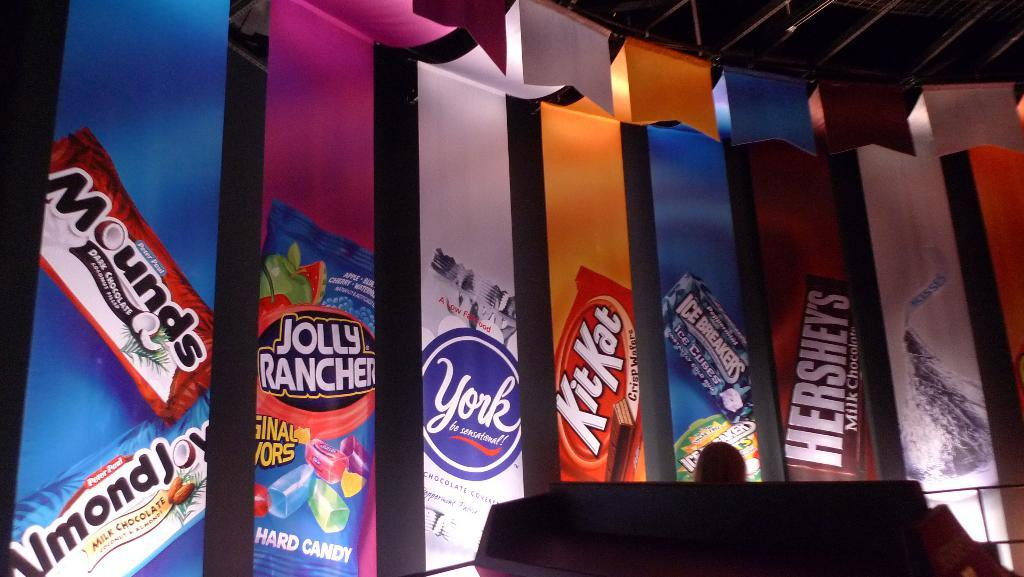What can be seen hanging from the rods and ropes at the top of the image? There are banners in the image that are hanging from the rods and ropes. What are the rods and ropes used for in the image? The rods and ropes are used to hold up the banners in the image. What color is the object at the bottom of the image? There is a black color object at the bottom of the image. Can you identify any human features in the image? Yes, a human head is visible in the image. What type of agreement is being discussed by the visitor and the father in the image? There is no visitor or father present in the image, and therefore no such discussion can be observed. 